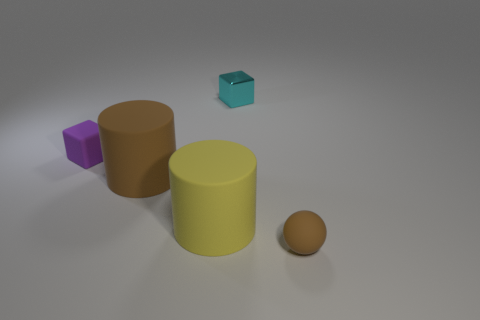Is there any other thing that has the same material as the tiny cyan cube?
Ensure brevity in your answer.  No. What material is the thing that is in front of the big brown rubber thing and behind the brown rubber sphere?
Keep it short and to the point. Rubber. Do the yellow rubber thing and the tiny metallic object have the same shape?
Offer a terse response. No. Is there any other thing that is the same size as the brown matte ball?
Offer a very short reply. Yes. What number of blocks are to the right of the purple matte cube?
Your answer should be very brief. 1. There is a brown object behind the brown matte sphere; is it the same size as the purple matte cube?
Your answer should be compact. No. There is another tiny thing that is the same shape as the metal thing; what is its color?
Give a very brief answer. Purple. Are there any other things that are the same shape as the large brown object?
Offer a terse response. Yes. What shape is the small thing behind the tiny rubber block?
Your answer should be compact. Cube. What number of brown rubber objects are the same shape as the big yellow object?
Your response must be concise. 1. 